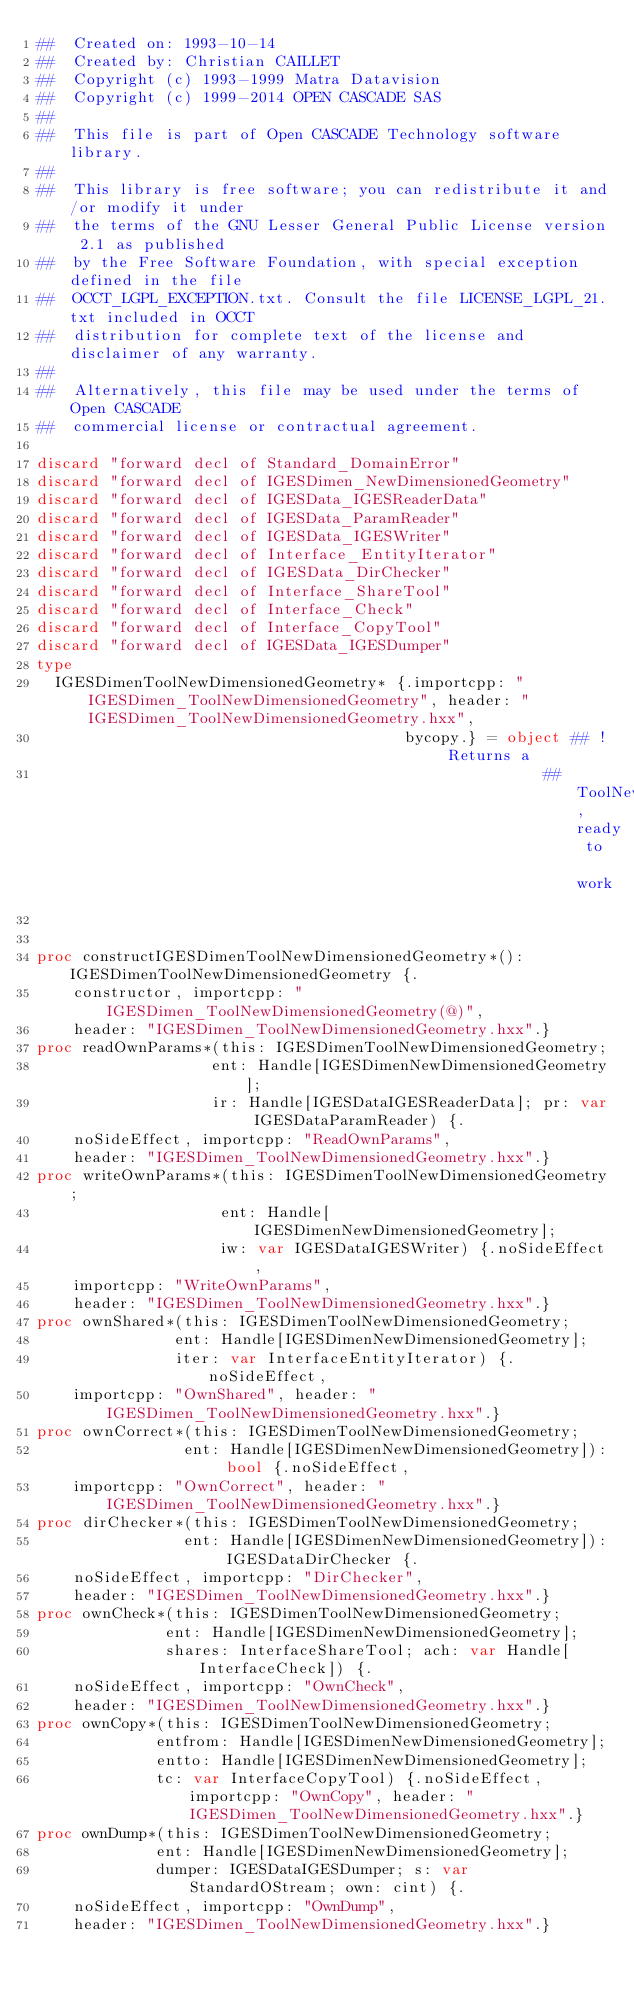<code> <loc_0><loc_0><loc_500><loc_500><_Nim_>##  Created on: 1993-10-14
##  Created by: Christian CAILLET
##  Copyright (c) 1993-1999 Matra Datavision
##  Copyright (c) 1999-2014 OPEN CASCADE SAS
##
##  This file is part of Open CASCADE Technology software library.
##
##  This library is free software; you can redistribute it and/or modify it under
##  the terms of the GNU Lesser General Public License version 2.1 as published
##  by the Free Software Foundation, with special exception defined in the file
##  OCCT_LGPL_EXCEPTION.txt. Consult the file LICENSE_LGPL_21.txt included in OCCT
##  distribution for complete text of the license and disclaimer of any warranty.
##
##  Alternatively, this file may be used under the terms of Open CASCADE
##  commercial license or contractual agreement.

discard "forward decl of Standard_DomainError"
discard "forward decl of IGESDimen_NewDimensionedGeometry"
discard "forward decl of IGESData_IGESReaderData"
discard "forward decl of IGESData_ParamReader"
discard "forward decl of IGESData_IGESWriter"
discard "forward decl of Interface_EntityIterator"
discard "forward decl of IGESData_DirChecker"
discard "forward decl of Interface_ShareTool"
discard "forward decl of Interface_Check"
discard "forward decl of Interface_CopyTool"
discard "forward decl of IGESData_IGESDumper"
type
  IGESDimenToolNewDimensionedGeometry* {.importcpp: "IGESDimen_ToolNewDimensionedGeometry", header: "IGESDimen_ToolNewDimensionedGeometry.hxx",
                                        bycopy.} = object ## ! Returns a
                                                       ## ToolNewDimensionedGeometry, ready to work


proc constructIGESDimenToolNewDimensionedGeometry*(): IGESDimenToolNewDimensionedGeometry {.
    constructor, importcpp: "IGESDimen_ToolNewDimensionedGeometry(@)",
    header: "IGESDimen_ToolNewDimensionedGeometry.hxx".}
proc readOwnParams*(this: IGESDimenToolNewDimensionedGeometry;
                   ent: Handle[IGESDimenNewDimensionedGeometry];
                   ir: Handle[IGESDataIGESReaderData]; pr: var IGESDataParamReader) {.
    noSideEffect, importcpp: "ReadOwnParams",
    header: "IGESDimen_ToolNewDimensionedGeometry.hxx".}
proc writeOwnParams*(this: IGESDimenToolNewDimensionedGeometry;
                    ent: Handle[IGESDimenNewDimensionedGeometry];
                    iw: var IGESDataIGESWriter) {.noSideEffect,
    importcpp: "WriteOwnParams",
    header: "IGESDimen_ToolNewDimensionedGeometry.hxx".}
proc ownShared*(this: IGESDimenToolNewDimensionedGeometry;
               ent: Handle[IGESDimenNewDimensionedGeometry];
               iter: var InterfaceEntityIterator) {.noSideEffect,
    importcpp: "OwnShared", header: "IGESDimen_ToolNewDimensionedGeometry.hxx".}
proc ownCorrect*(this: IGESDimenToolNewDimensionedGeometry;
                ent: Handle[IGESDimenNewDimensionedGeometry]): bool {.noSideEffect,
    importcpp: "OwnCorrect", header: "IGESDimen_ToolNewDimensionedGeometry.hxx".}
proc dirChecker*(this: IGESDimenToolNewDimensionedGeometry;
                ent: Handle[IGESDimenNewDimensionedGeometry]): IGESDataDirChecker {.
    noSideEffect, importcpp: "DirChecker",
    header: "IGESDimen_ToolNewDimensionedGeometry.hxx".}
proc ownCheck*(this: IGESDimenToolNewDimensionedGeometry;
              ent: Handle[IGESDimenNewDimensionedGeometry];
              shares: InterfaceShareTool; ach: var Handle[InterfaceCheck]) {.
    noSideEffect, importcpp: "OwnCheck",
    header: "IGESDimen_ToolNewDimensionedGeometry.hxx".}
proc ownCopy*(this: IGESDimenToolNewDimensionedGeometry;
             entfrom: Handle[IGESDimenNewDimensionedGeometry];
             entto: Handle[IGESDimenNewDimensionedGeometry];
             tc: var InterfaceCopyTool) {.noSideEffect, importcpp: "OwnCopy", header: "IGESDimen_ToolNewDimensionedGeometry.hxx".}
proc ownDump*(this: IGESDimenToolNewDimensionedGeometry;
             ent: Handle[IGESDimenNewDimensionedGeometry];
             dumper: IGESDataIGESDumper; s: var StandardOStream; own: cint) {.
    noSideEffect, importcpp: "OwnDump",
    header: "IGESDimen_ToolNewDimensionedGeometry.hxx".}

























</code> 